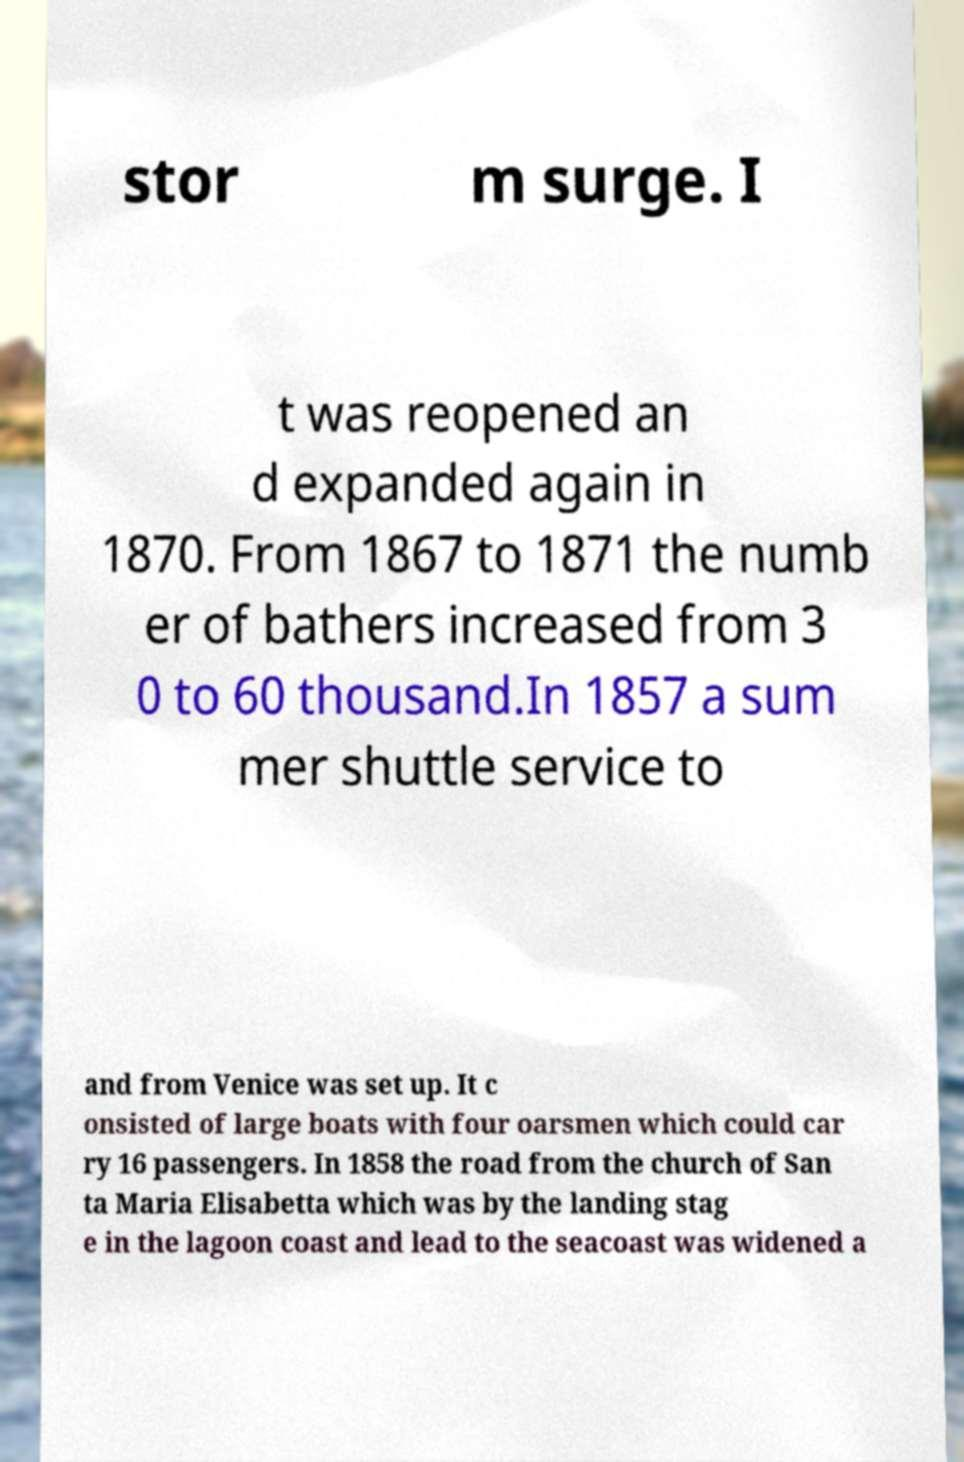What messages or text are displayed in this image? I need them in a readable, typed format. stor m surge. I t was reopened an d expanded again in 1870. From 1867 to 1871 the numb er of bathers increased from 3 0 to 60 thousand.In 1857 a sum mer shuttle service to and from Venice was set up. It c onsisted of large boats with four oarsmen which could car ry 16 passengers. In 1858 the road from the church of San ta Maria Elisabetta which was by the landing stag e in the lagoon coast and lead to the seacoast was widened a 